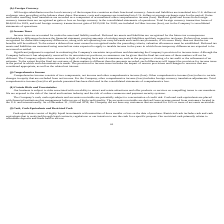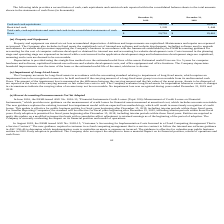From Travelzoo's financial document, What is the cash and cash equivalents as of December 31, 2019 and 2018 respectively? The document shows two values: $19,505 and $18,017 (in thousands). From the document: "Cash and cash equivalents $ 19,505 $ 18,017 Cash and cash equivalents $ 19,505 $ 18,017..." Also, What is the restricted cash amount as of December 31, 2019 and 2018 respectively? The document shows two values: 1,205 and 1,444 (in thousands). From the document: "Restricted cash 1,205 1,444 Restricted cash 1,205 1,444..." Also, What does restricted cash primarily relate to? refundable deposits and funds held in escrow. The document states: "purpose. Our restricted cash primarily relates to refundable deposits and funds held in escrow...." Also, can you calculate: What is the change in the cash and cash equivalents between 2019 and 2018? Based on the calculation: 19,505-18,017, the result is 1488 (in thousands). This is based on the information: "Cash and cash equivalents $ 19,505 $ 18,017 Cash and cash equivalents $ 19,505 $ 18,017..." The key data points involved are: 18,017, 19,505. Also, can you calculate: What is the average restricted cash amount in 2018 and 2019? To answer this question, I need to perform calculations using the financial data. The calculation is: (1,205+1,444)/2, which equals 1324.5 (in thousands). This is based on the information: "Restricted cash 1,205 1,444 Restricted cash 1,205 1,444..." The key data points involved are: 1,205, 1,444. Additionally, Which year has the higher amount of cash and cash equivalents? According to the financial document, 2019. The relevant text states: "oreign currency transaction losses of $64,000 for 2019, and total foreign currency transaction net gain of $135,000 for 2018, are included in Other income..." 